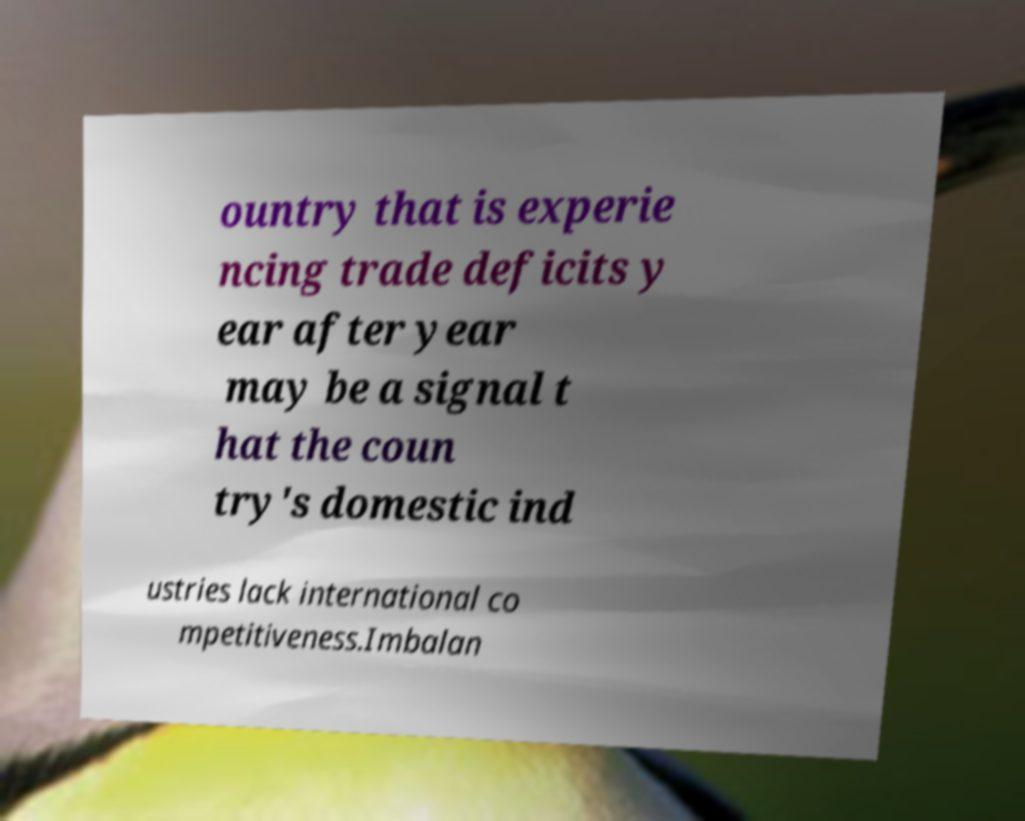Please identify and transcribe the text found in this image. ountry that is experie ncing trade deficits y ear after year may be a signal t hat the coun try's domestic ind ustries lack international co mpetitiveness.Imbalan 